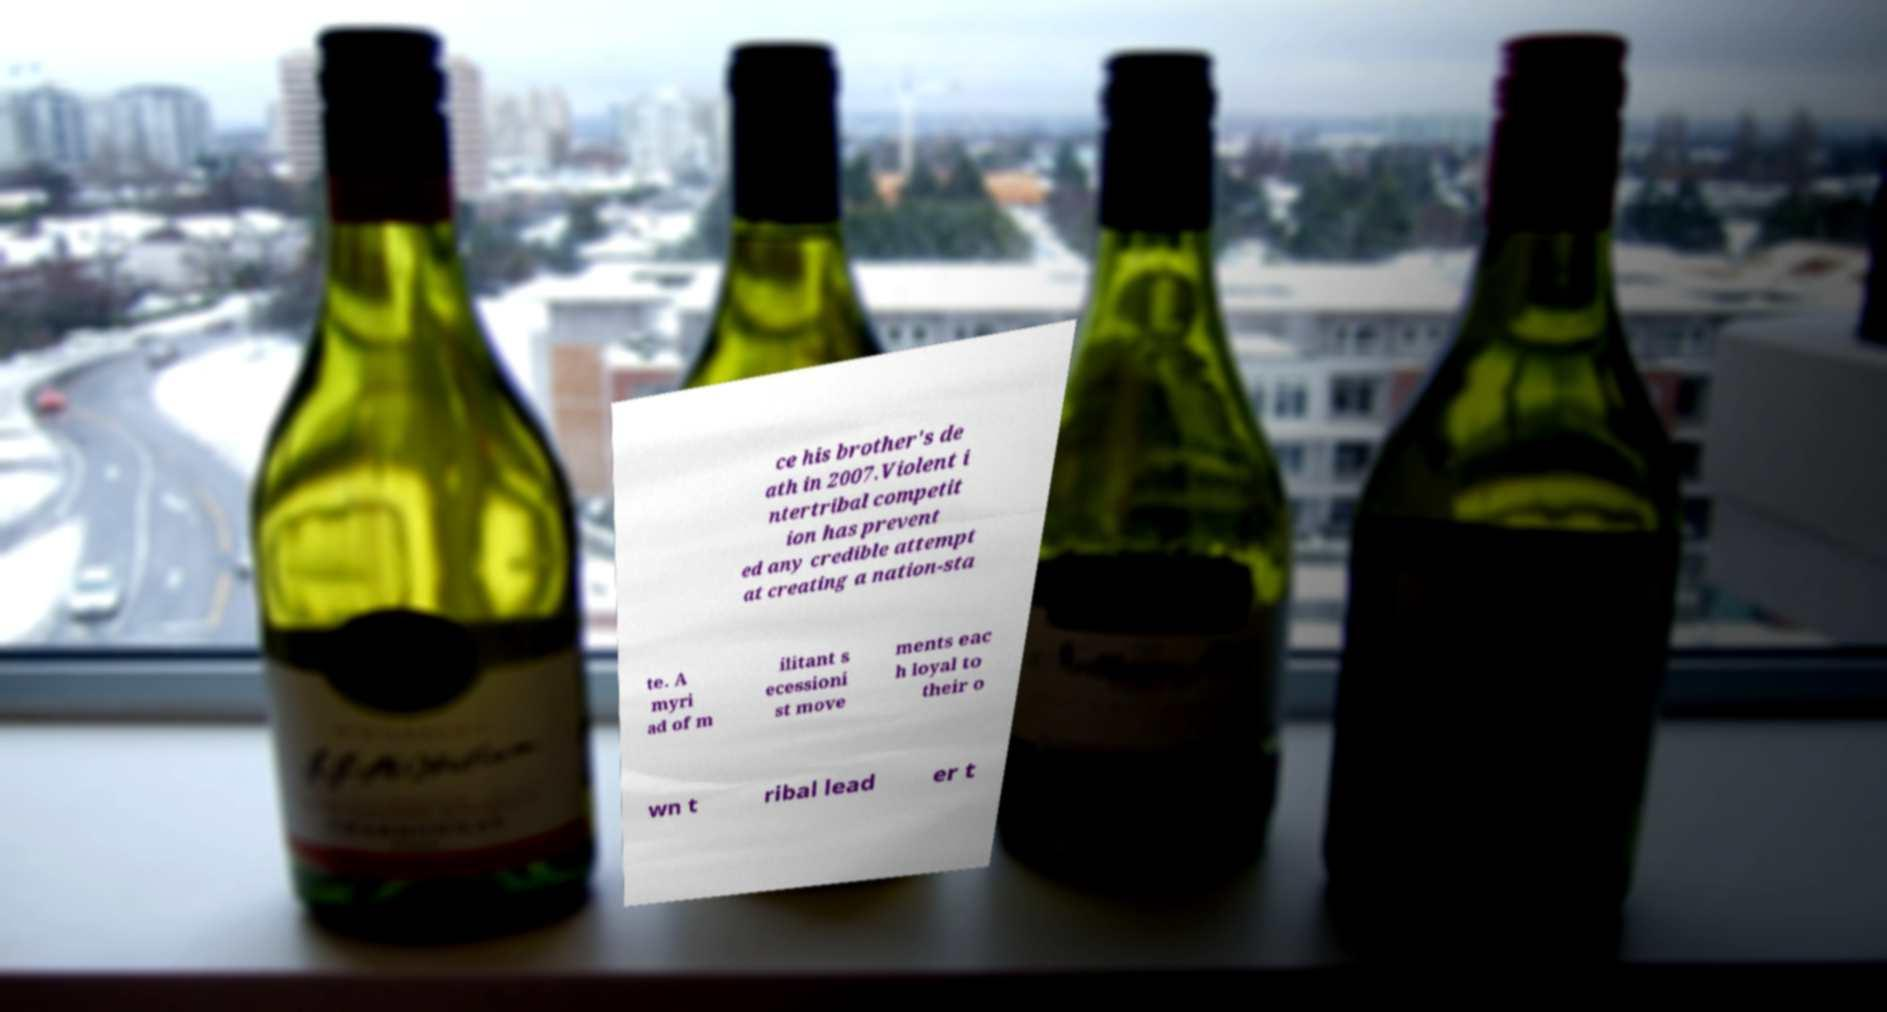There's text embedded in this image that I need extracted. Can you transcribe it verbatim? ce his brother's de ath in 2007.Violent i ntertribal competit ion has prevent ed any credible attempt at creating a nation-sta te. A myri ad of m ilitant s ecessioni st move ments eac h loyal to their o wn t ribal lead er t 